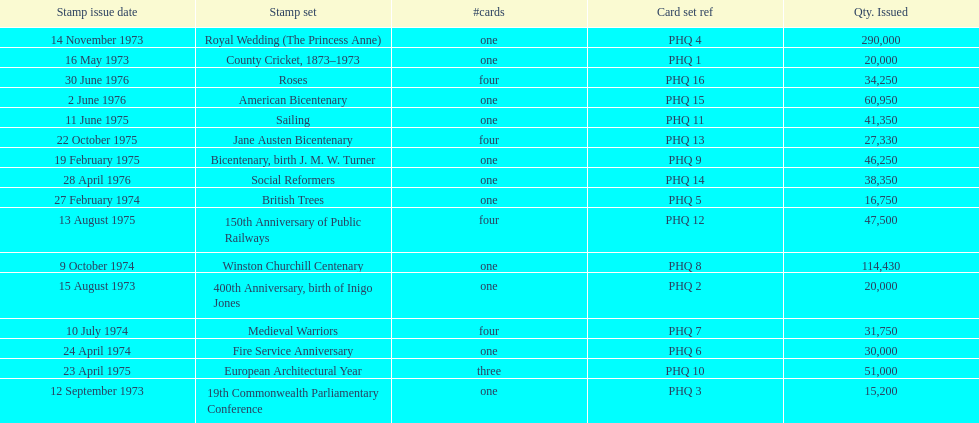Which stamp set had the greatest quantity issued? Royal Wedding (The Princess Anne). 